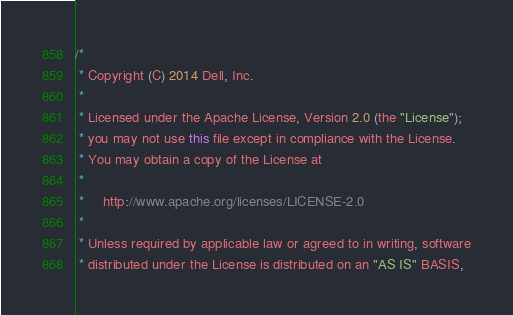<code> <loc_0><loc_0><loc_500><loc_500><_Java_>/*
 * Copyright (C) 2014 Dell, Inc.
 * 
 * Licensed under the Apache License, Version 2.0 (the "License");
 * you may not use this file except in compliance with the License.
 * You may obtain a copy of the License at
 * 
 *     http://www.apache.org/licenses/LICENSE-2.0
 * 
 * Unless required by applicable law or agreed to in writing, software
 * distributed under the License is distributed on an "AS IS" BASIS,</code> 